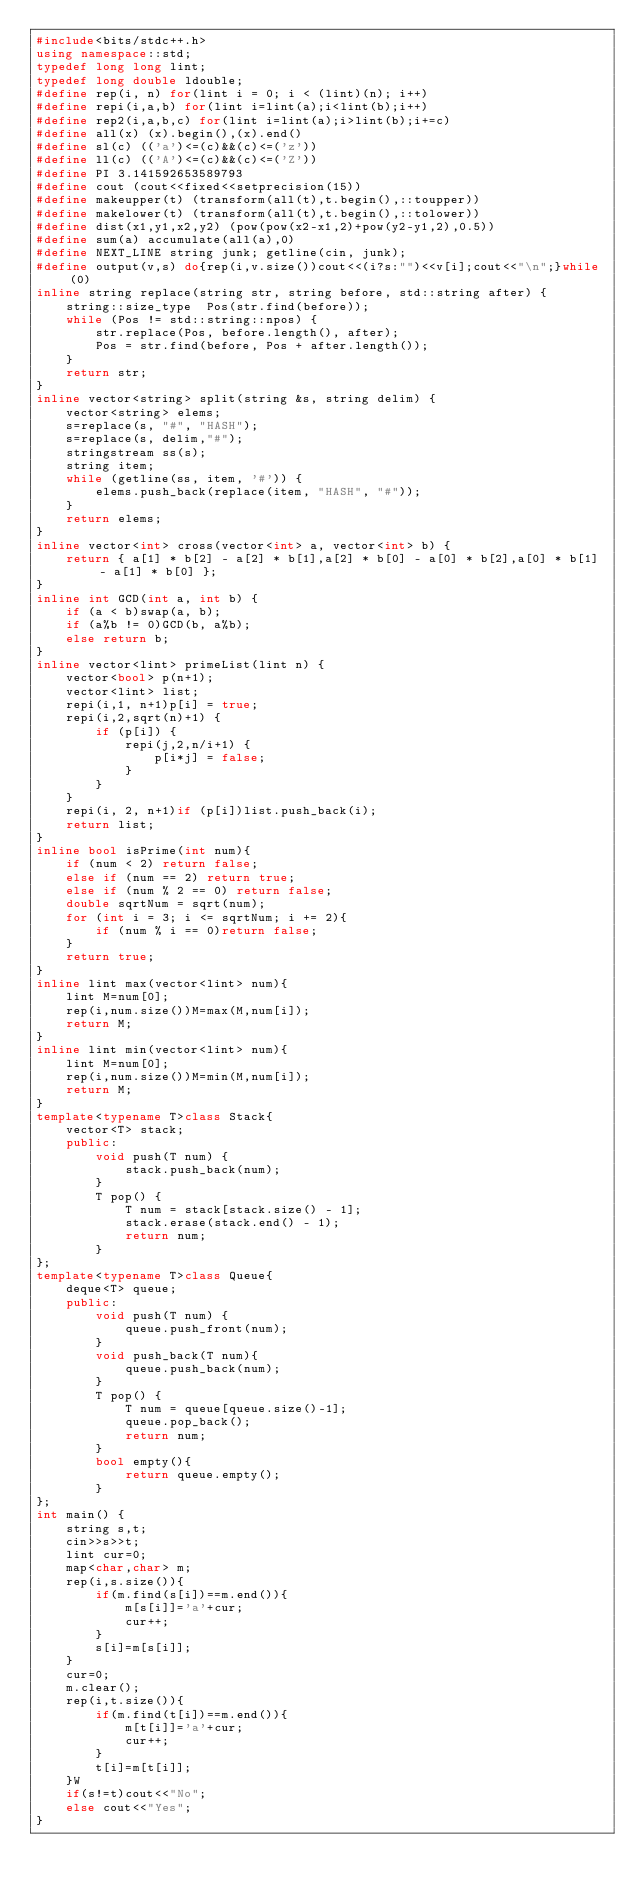<code> <loc_0><loc_0><loc_500><loc_500><_C++_>#include<bits/stdc++.h>
using namespace::std;
typedef long long lint;
typedef long double ldouble;
#define rep(i, n) for(lint i = 0; i < (lint)(n); i++)
#define repi(i,a,b) for(lint i=lint(a);i<lint(b);i++)
#define rep2(i,a,b,c) for(lint i=lint(a);i>lint(b);i+=c)
#define all(x) (x).begin(),(x).end()
#define sl(c) (('a')<=(c)&&(c)<=('z'))
#define ll(c) (('A')<=(c)&&(c)<=('Z'))
#define PI 3.141592653589793
#define cout (cout<<fixed<<setprecision(15))
#define makeupper(t) (transform(all(t),t.begin(),::toupper))
#define makelower(t) (transform(all(t),t.begin(),::tolower))
#define dist(x1,y1,x2,y2) (pow(pow(x2-x1,2)+pow(y2-y1,2),0.5))
#define sum(a) accumulate(all(a),0)
#define NEXT_LINE string junk; getline(cin, junk);
#define output(v,s) do{rep(i,v.size())cout<<(i?s:"")<<v[i];cout<<"\n";}while(0)
inline string replace(string str, string before, std::string after) {
	string::size_type  Pos(str.find(before));
	while (Pos != std::string::npos) {
		str.replace(Pos, before.length(), after);
		Pos = str.find(before, Pos + after.length());
	}
	return str;
}
inline vector<string> split(string &s, string delim) {
	vector<string> elems;
	s=replace(s, "#", "HASH");
	s=replace(s, delim,"#");
	stringstream ss(s);
	string item;
	while (getline(ss, item, '#')) {
		elems.push_back(replace(item, "HASH", "#"));
	}
	return elems;
}
inline vector<int> cross(vector<int> a, vector<int> b) {
    return { a[1] * b[2] - a[2] * b[1],a[2] * b[0] - a[0] * b[2],a[0] * b[1] - a[1] * b[0] };
}
inline int GCD(int a, int b) {
    if (a < b)swap(a, b);
    if (a%b != 0)GCD(b, a%b);
    else return b;
}
inline vector<lint> primeList(lint n) {
    vector<bool> p(n+1);
    vector<lint> list;
    repi(i,1, n+1)p[i] = true;
    repi(i,2,sqrt(n)+1) {
        if (p[i]) {
            repi(j,2,n/i+1) {
                p[i*j] = false;
            }
        }
    }
    repi(i, 2, n+1)if (p[i])list.push_back(i);
    return list;
}
inline bool isPrime(int num){
    if (num < 2) return false;
    else if (num == 2) return true;
    else if (num % 2 == 0) return false;
    double sqrtNum = sqrt(num);
    for (int i = 3; i <= sqrtNum; i += 2){
        if (num % i == 0)return false;
    }
    return true;
}
inline lint max(vector<lint> num){
    lint M=num[0];
    rep(i,num.size())M=max(M,num[i]);
    return M;
}
inline lint min(vector<lint> num){
    lint M=num[0];
    rep(i,num.size())M=min(M,num[i]);
    return M;
}
template<typename T>class Stack{
    vector<T> stack;
    public:
        void push(T num) {
            stack.push_back(num);
        }
        T pop() {
            T num = stack[stack.size() - 1];
            stack.erase(stack.end() - 1);
            return num;
        }
};
template<typename T>class Queue{
    deque<T> queue;
    public:
        void push(T num) {
            queue.push_front(num);
        }
		void push_back(T num){
			queue.push_back(num);
		}
        T pop() {
            T num = queue[queue.size()-1];
            queue.pop_back();
            return num;
        }
        bool empty(){
            return queue.empty();
        }
};
int main() {
    string s,t;
    cin>>s>>t;
    lint cur=0;
    map<char,char> m;
    rep(i,s.size()){
        if(m.find(s[i])==m.end()){
            m[s[i]]='a'+cur;
            cur++;
        }
        s[i]=m[s[i]];
    }
    cur=0;
    m.clear();
    rep(i,t.size()){
        if(m.find(t[i])==m.end()){
            m[t[i]]='a'+cur;
            cur++;
        }
        t[i]=m[t[i]];
    }W
    if(s!=t)cout<<"No";
    else cout<<"Yes";
}</code> 